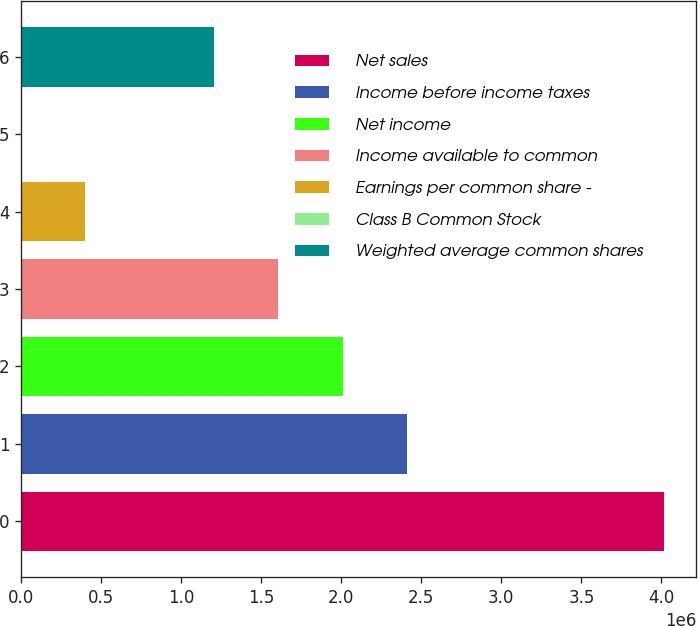Convert chart. <chart><loc_0><loc_0><loc_500><loc_500><bar_chart><fcel>Net sales<fcel>Income before income taxes<fcel>Net income<fcel>Income available to common<fcel>Earnings per common share -<fcel>Class B Common Stock<fcel>Weighted average common shares<nl><fcel>4.01744e+06<fcel>2.41046e+06<fcel>2.00872e+06<fcel>1.60698e+06<fcel>401745<fcel>1.1<fcel>1.20523e+06<nl></chart> 